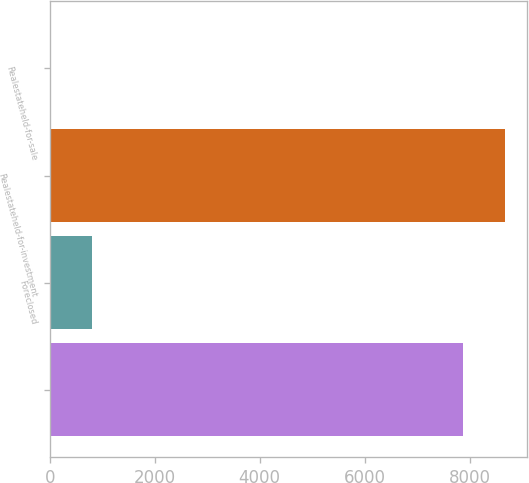Convert chart. <chart><loc_0><loc_0><loc_500><loc_500><bar_chart><ecel><fcel>Foreclosed<fcel>Realestateheld-for-investment<fcel>Realestateheld-for-sale<nl><fcel>7870<fcel>809.4<fcel>8671.4<fcel>8<nl></chart> 